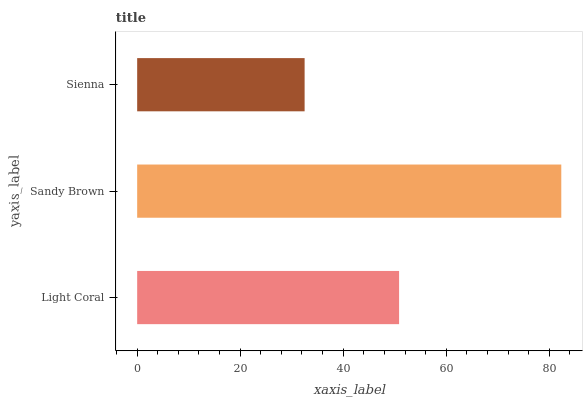Is Sienna the minimum?
Answer yes or no. Yes. Is Sandy Brown the maximum?
Answer yes or no. Yes. Is Sandy Brown the minimum?
Answer yes or no. No. Is Sienna the maximum?
Answer yes or no. No. Is Sandy Brown greater than Sienna?
Answer yes or no. Yes. Is Sienna less than Sandy Brown?
Answer yes or no. Yes. Is Sienna greater than Sandy Brown?
Answer yes or no. No. Is Sandy Brown less than Sienna?
Answer yes or no. No. Is Light Coral the high median?
Answer yes or no. Yes. Is Light Coral the low median?
Answer yes or no. Yes. Is Sienna the high median?
Answer yes or no. No. Is Sandy Brown the low median?
Answer yes or no. No. 